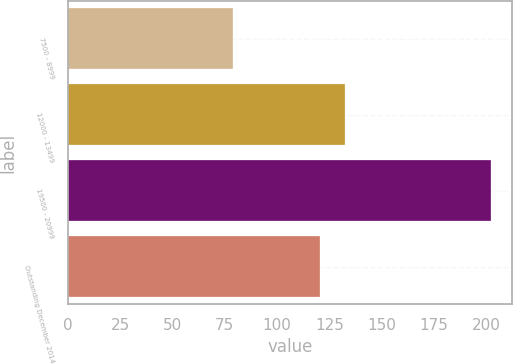Convert chart to OTSL. <chart><loc_0><loc_0><loc_500><loc_500><bar_chart><fcel>7500 - 8999<fcel>12000 - 13499<fcel>19500 - 20999<fcel>Outstanding December 2014<nl><fcel>78.78<fcel>132.75<fcel>202.27<fcel>120.4<nl></chart> 